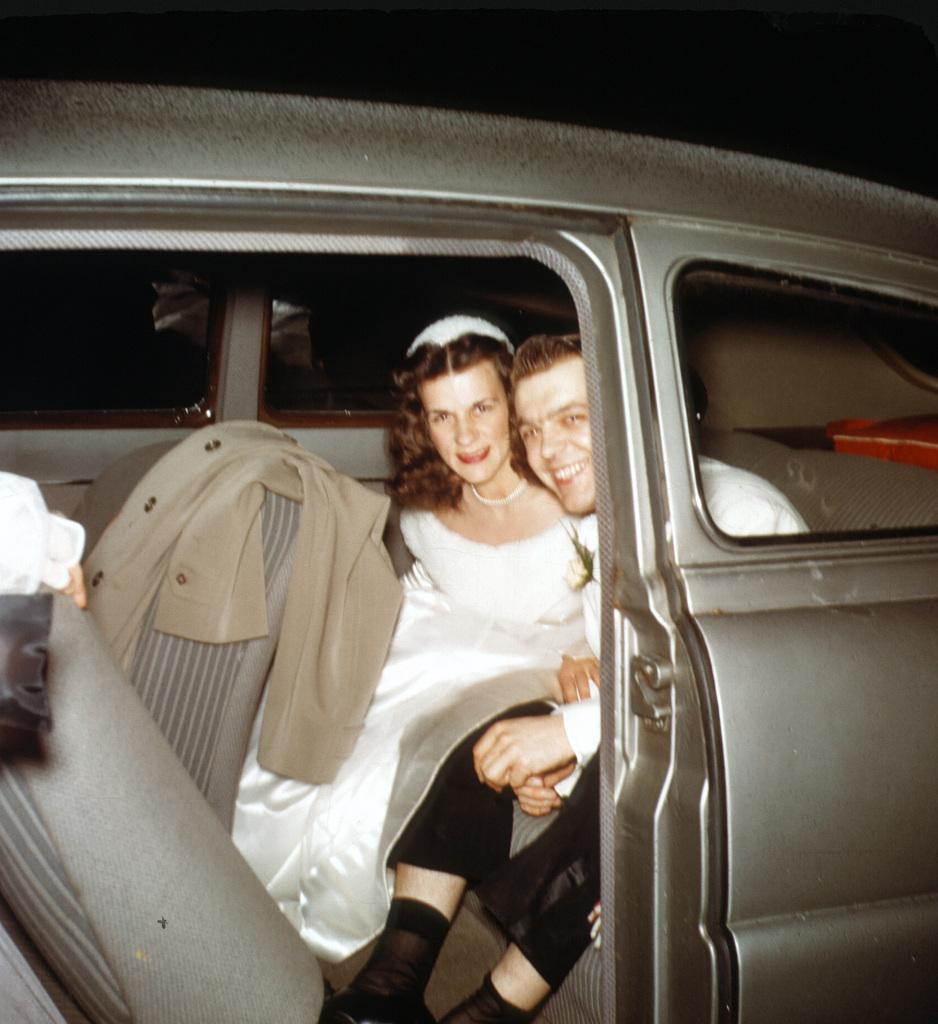In one or two sentences, can you explain what this image depicts? In this picture there is a man and a woman sitting in a car. There is a jacket and a cloth. 